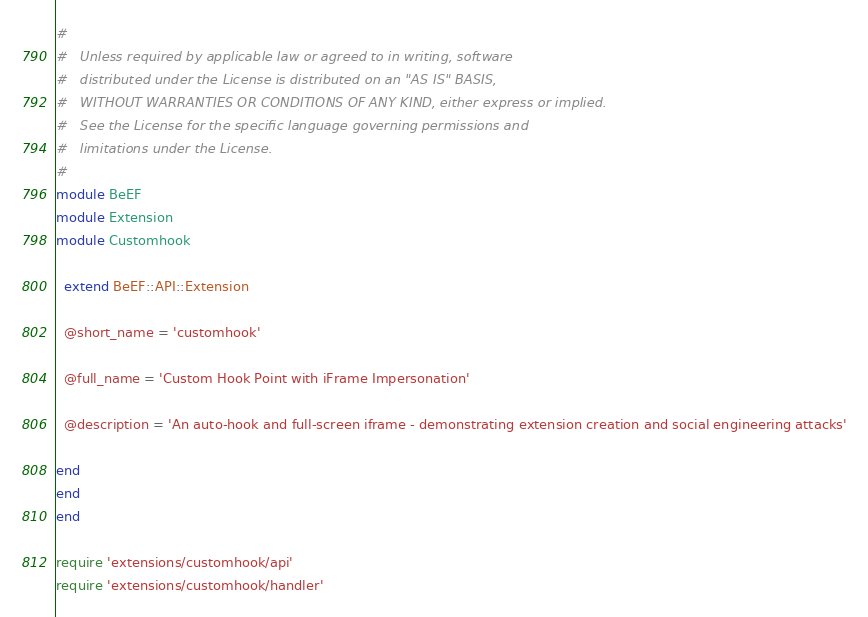<code> <loc_0><loc_0><loc_500><loc_500><_Ruby_>#
#   Unless required by applicable law or agreed to in writing, software
#   distributed under the License is distributed on an "AS IS" BASIS,
#   WITHOUT WARRANTIES OR CONDITIONS OF ANY KIND, either express or implied.
#   See the License for the specific language governing permissions and
#   limitations under the License.
#
module BeEF
module Extension
module Customhook
  
  extend BeEF::API::Extension
  
  @short_name = 'customhook'
  
  @full_name = 'Custom Hook Point with iFrame Impersonation'
  
  @description = 'An auto-hook and full-screen iframe - demonstrating extension creation and social engineering attacks'
  
end
end
end

require 'extensions/customhook/api'
require 'extensions/customhook/handler'
</code> 